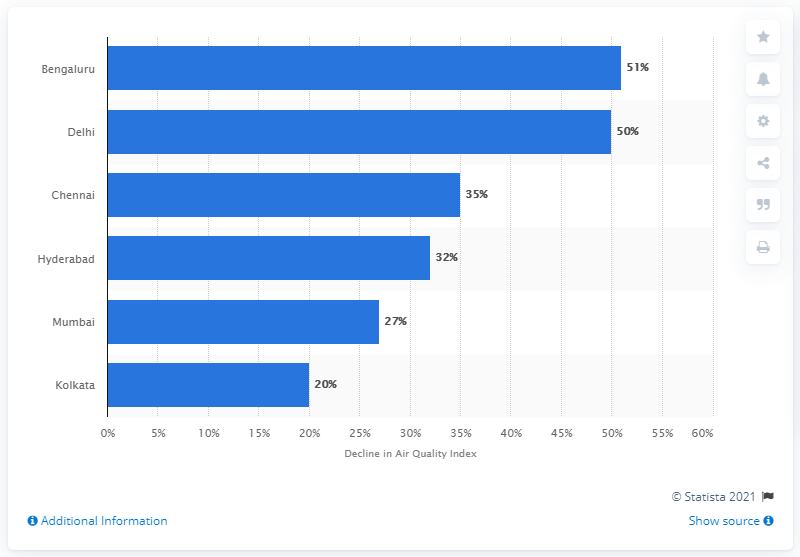Draw attention to some important aspects in this diagram. The air quality index in Bengaluru declined significantly in 2020, with a decrease of 51 points. 